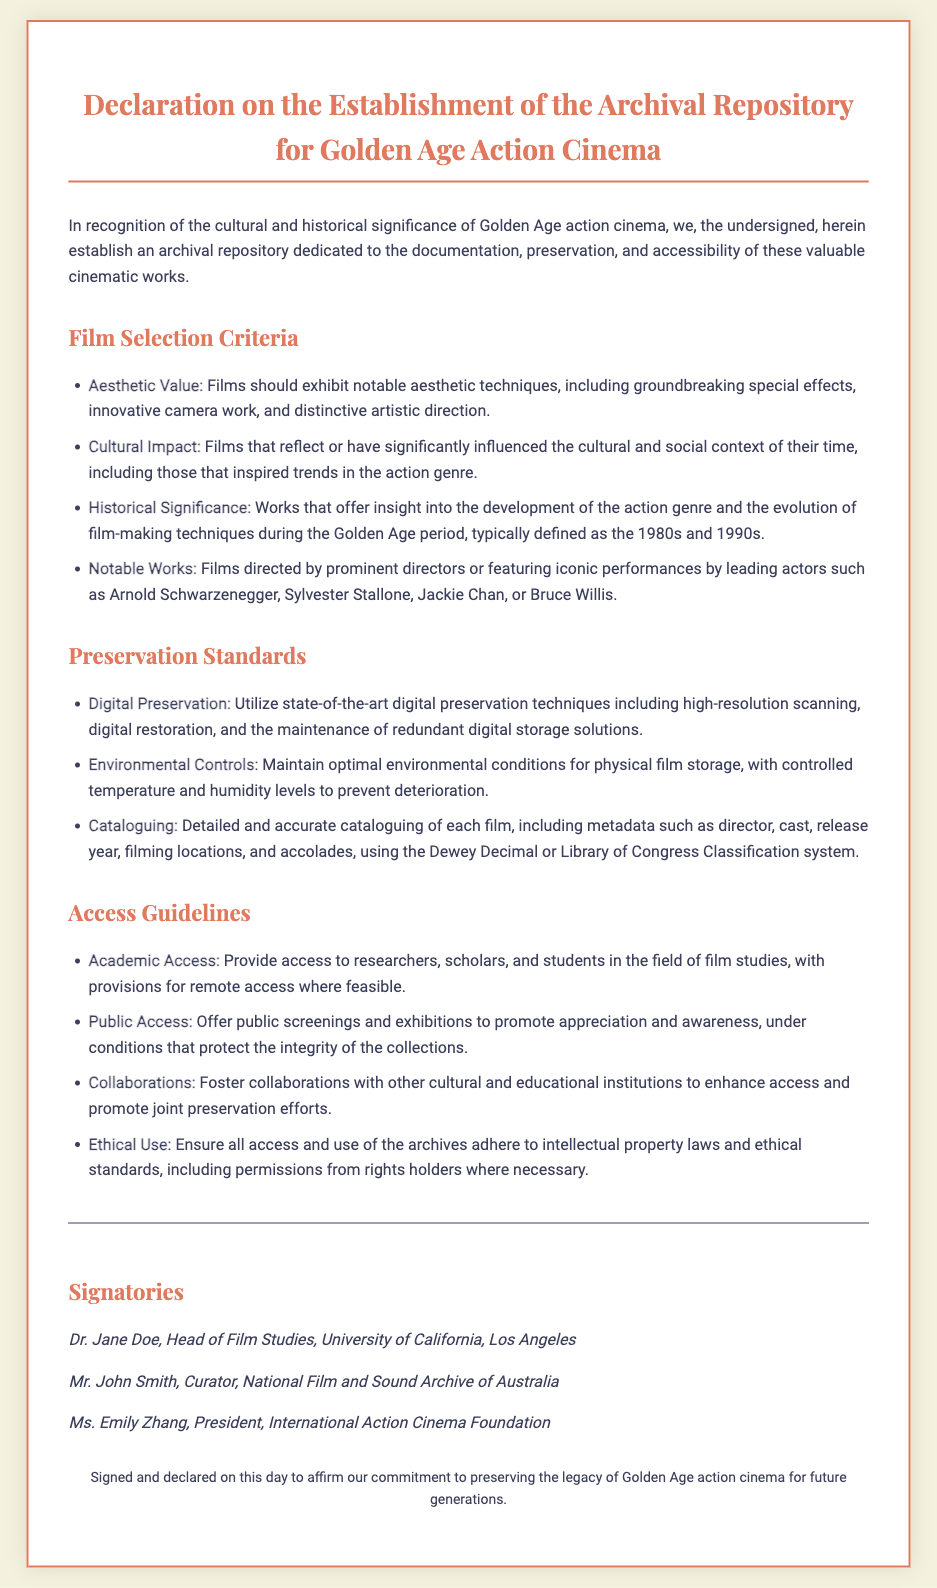What is the purpose of the declaration? The declaration establishes an archival repository dedicated to the documentation, preservation, and accessibility of Golden Age action cinema.
Answer: archival repository What years define the Golden Age period? The document specifies the Golden Age period as the 1980s and 1990s.
Answer: 1980s and 1990s Who is the first signatory? The first signatory mentioned is Dr. Jane Doe, who is Head of Film Studies at the University of California, Los Angeles.
Answer: Dr. Jane Doe What is one criterion for film selection? One of the criteria for film selection includes cultural impact, which reflects films that have significantly influenced the cultural and social context of their time.
Answer: cultural impact Which classification system is used for cataloguing? The document mentions using the Dewey Decimal or Library of Congress Classification system for cataloguing.
Answer: Dewey Decimal or Library of Congress Classification How are preservation standards described? Preservation standards are described as utilizing state-of-the-art digital preservation techniques and maintaining optimal environmental conditions.
Answer: state-of-the-art digital preservation techniques What access provision is mentioned for academic users? The document states that access is provided to researchers, scholars, and students in the field of film studies.
Answer: researchers, scholars, and students What type of collaborations are encouraged? The document encourages fostering collaborations with other cultural and educational institutions to enhance access and promote joint preservation efforts.
Answer: collaborations with other cultural and educational institutions 